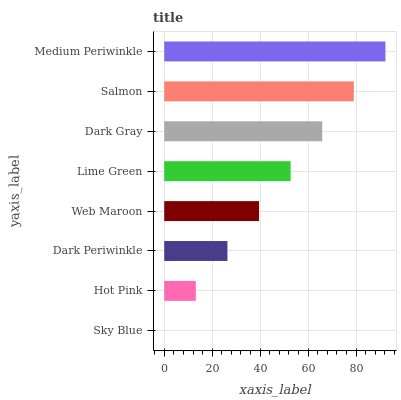Is Sky Blue the minimum?
Answer yes or no. Yes. Is Medium Periwinkle the maximum?
Answer yes or no. Yes. Is Hot Pink the minimum?
Answer yes or no. No. Is Hot Pink the maximum?
Answer yes or no. No. Is Hot Pink greater than Sky Blue?
Answer yes or no. Yes. Is Sky Blue less than Hot Pink?
Answer yes or no. Yes. Is Sky Blue greater than Hot Pink?
Answer yes or no. No. Is Hot Pink less than Sky Blue?
Answer yes or no. No. Is Lime Green the high median?
Answer yes or no. Yes. Is Web Maroon the low median?
Answer yes or no. Yes. Is Dark Gray the high median?
Answer yes or no. No. Is Dark Gray the low median?
Answer yes or no. No. 